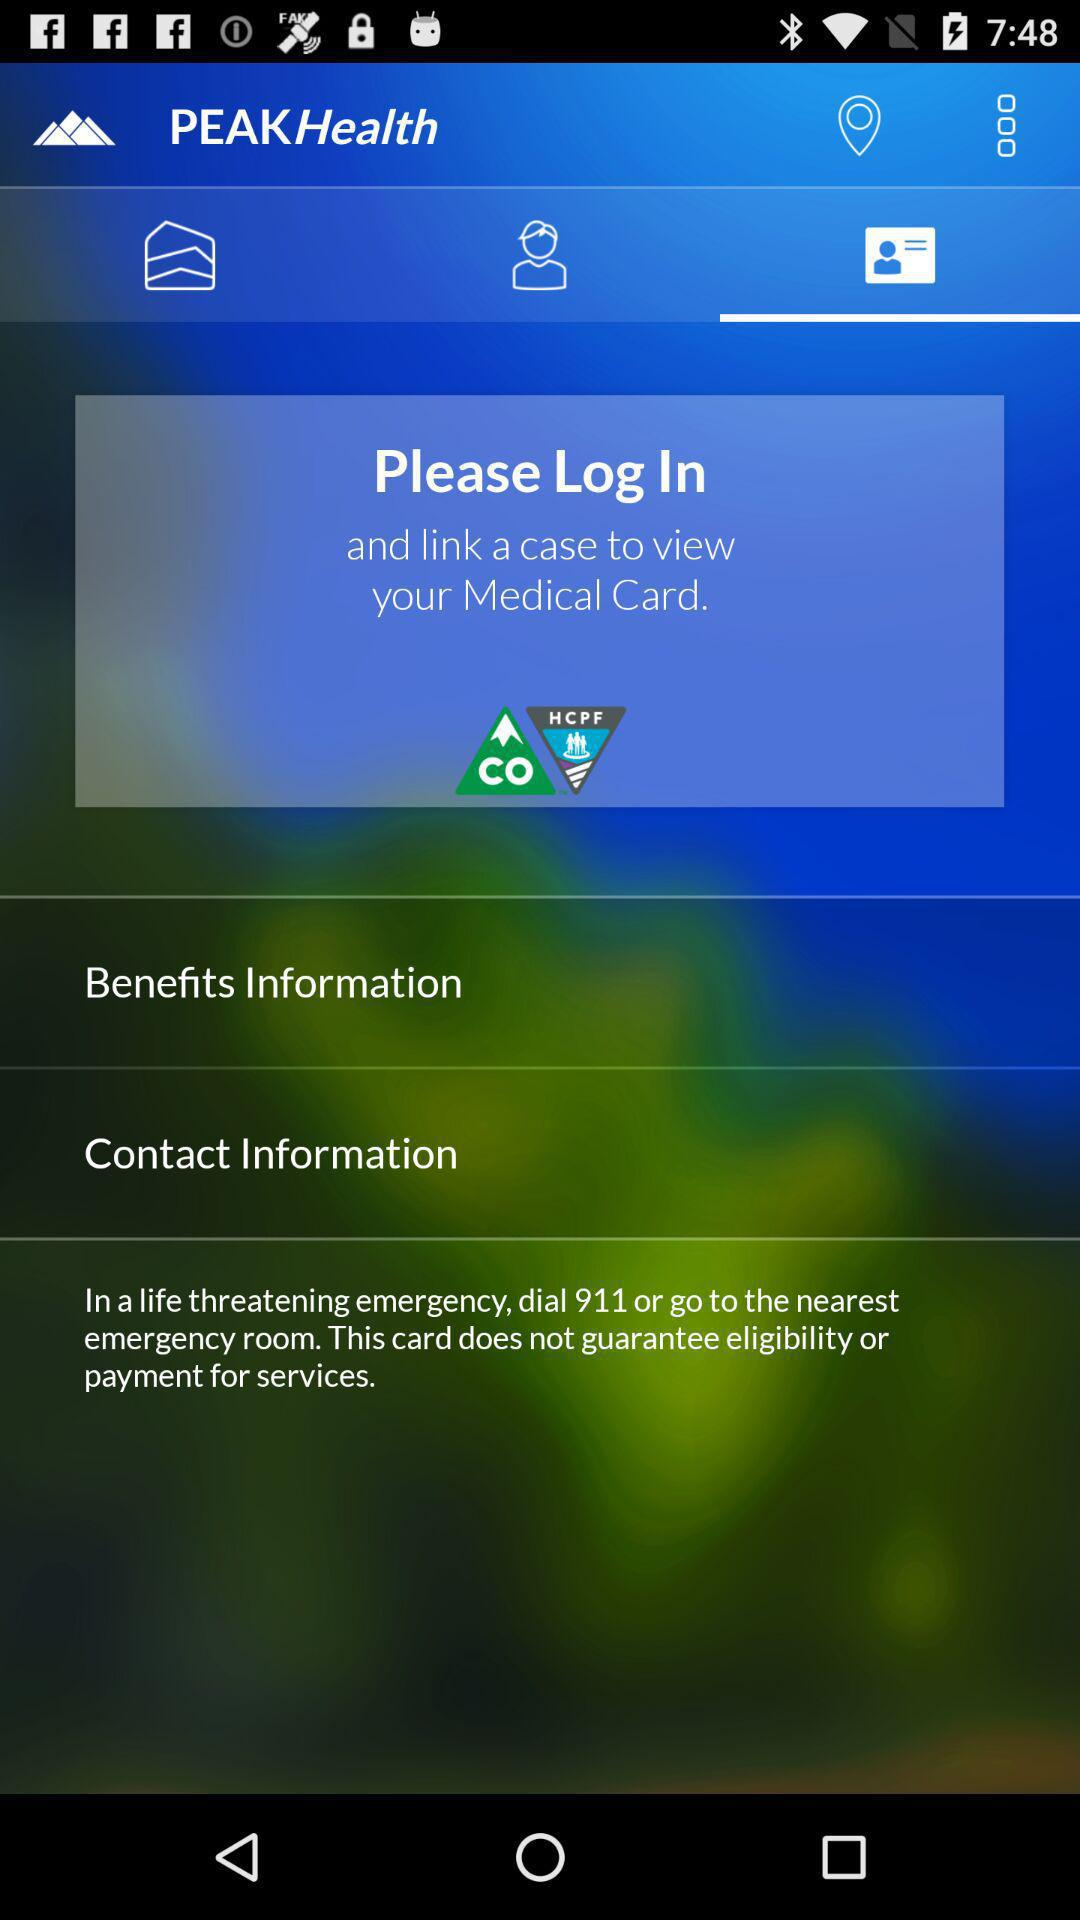Which tab has been selected? The selected tab is "Identity Card". 